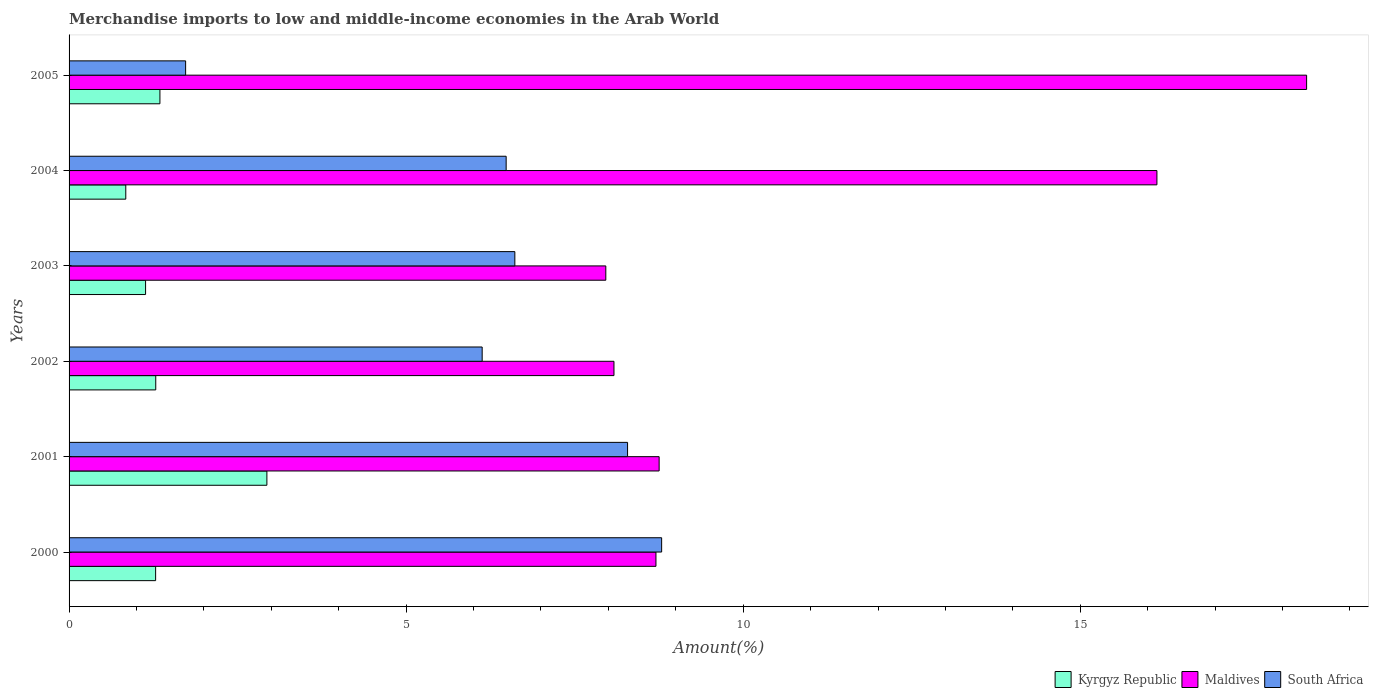Are the number of bars on each tick of the Y-axis equal?
Your answer should be very brief. Yes. How many bars are there on the 1st tick from the top?
Keep it short and to the point. 3. How many bars are there on the 4th tick from the bottom?
Make the answer very short. 3. In how many cases, is the number of bars for a given year not equal to the number of legend labels?
Your response must be concise. 0. What is the percentage of amount earned from merchandise imports in South Africa in 2005?
Keep it short and to the point. 1.73. Across all years, what is the maximum percentage of amount earned from merchandise imports in Kyrgyz Republic?
Offer a very short reply. 2.93. Across all years, what is the minimum percentage of amount earned from merchandise imports in Kyrgyz Republic?
Offer a terse response. 0.84. In which year was the percentage of amount earned from merchandise imports in Maldives minimum?
Provide a succinct answer. 2003. What is the total percentage of amount earned from merchandise imports in Maldives in the graph?
Your answer should be very brief. 68. What is the difference between the percentage of amount earned from merchandise imports in Kyrgyz Republic in 2000 and that in 2001?
Keep it short and to the point. -1.65. What is the difference between the percentage of amount earned from merchandise imports in South Africa in 2004 and the percentage of amount earned from merchandise imports in Kyrgyz Republic in 2002?
Provide a short and direct response. 5.2. What is the average percentage of amount earned from merchandise imports in South Africa per year?
Give a very brief answer. 6.34. In the year 2004, what is the difference between the percentage of amount earned from merchandise imports in Maldives and percentage of amount earned from merchandise imports in Kyrgyz Republic?
Your response must be concise. 15.3. What is the ratio of the percentage of amount earned from merchandise imports in Maldives in 2003 to that in 2005?
Offer a very short reply. 0.43. Is the difference between the percentage of amount earned from merchandise imports in Maldives in 2000 and 2001 greater than the difference between the percentage of amount earned from merchandise imports in Kyrgyz Republic in 2000 and 2001?
Give a very brief answer. Yes. What is the difference between the highest and the second highest percentage of amount earned from merchandise imports in South Africa?
Offer a terse response. 0.51. What is the difference between the highest and the lowest percentage of amount earned from merchandise imports in Maldives?
Provide a short and direct response. 10.4. In how many years, is the percentage of amount earned from merchandise imports in Kyrgyz Republic greater than the average percentage of amount earned from merchandise imports in Kyrgyz Republic taken over all years?
Provide a short and direct response. 1. Is the sum of the percentage of amount earned from merchandise imports in South Africa in 2000 and 2002 greater than the maximum percentage of amount earned from merchandise imports in Kyrgyz Republic across all years?
Your answer should be compact. Yes. What does the 1st bar from the top in 2005 represents?
Provide a succinct answer. South Africa. What does the 2nd bar from the bottom in 2001 represents?
Offer a terse response. Maldives. Are all the bars in the graph horizontal?
Keep it short and to the point. Yes. Does the graph contain any zero values?
Your response must be concise. No. Where does the legend appear in the graph?
Offer a very short reply. Bottom right. How are the legend labels stacked?
Provide a short and direct response. Horizontal. What is the title of the graph?
Give a very brief answer. Merchandise imports to low and middle-income economies in the Arab World. Does "Peru" appear as one of the legend labels in the graph?
Your answer should be very brief. No. What is the label or title of the X-axis?
Offer a terse response. Amount(%). What is the label or title of the Y-axis?
Provide a succinct answer. Years. What is the Amount(%) of Kyrgyz Republic in 2000?
Provide a succinct answer. 1.28. What is the Amount(%) of Maldives in 2000?
Your answer should be very brief. 8.71. What is the Amount(%) in South Africa in 2000?
Your response must be concise. 8.79. What is the Amount(%) in Kyrgyz Republic in 2001?
Give a very brief answer. 2.93. What is the Amount(%) of Maldives in 2001?
Provide a succinct answer. 8.75. What is the Amount(%) in South Africa in 2001?
Provide a short and direct response. 8.28. What is the Amount(%) in Kyrgyz Republic in 2002?
Offer a terse response. 1.29. What is the Amount(%) of Maldives in 2002?
Keep it short and to the point. 8.08. What is the Amount(%) of South Africa in 2002?
Offer a terse response. 6.13. What is the Amount(%) of Kyrgyz Republic in 2003?
Your answer should be compact. 1.13. What is the Amount(%) of Maldives in 2003?
Your answer should be very brief. 7.96. What is the Amount(%) in South Africa in 2003?
Your answer should be very brief. 6.61. What is the Amount(%) in Kyrgyz Republic in 2004?
Make the answer very short. 0.84. What is the Amount(%) of Maldives in 2004?
Ensure brevity in your answer.  16.14. What is the Amount(%) in South Africa in 2004?
Ensure brevity in your answer.  6.48. What is the Amount(%) of Kyrgyz Republic in 2005?
Your answer should be compact. 1.35. What is the Amount(%) of Maldives in 2005?
Your answer should be very brief. 18.36. What is the Amount(%) of South Africa in 2005?
Provide a short and direct response. 1.73. Across all years, what is the maximum Amount(%) of Kyrgyz Republic?
Ensure brevity in your answer.  2.93. Across all years, what is the maximum Amount(%) in Maldives?
Ensure brevity in your answer.  18.36. Across all years, what is the maximum Amount(%) of South Africa?
Keep it short and to the point. 8.79. Across all years, what is the minimum Amount(%) in Kyrgyz Republic?
Make the answer very short. 0.84. Across all years, what is the minimum Amount(%) in Maldives?
Offer a very short reply. 7.96. Across all years, what is the minimum Amount(%) in South Africa?
Your response must be concise. 1.73. What is the total Amount(%) in Kyrgyz Republic in the graph?
Ensure brevity in your answer.  8.83. What is the total Amount(%) in Maldives in the graph?
Give a very brief answer. 68. What is the total Amount(%) of South Africa in the graph?
Your answer should be very brief. 38.03. What is the difference between the Amount(%) of Kyrgyz Republic in 2000 and that in 2001?
Your answer should be very brief. -1.65. What is the difference between the Amount(%) of Maldives in 2000 and that in 2001?
Your response must be concise. -0.05. What is the difference between the Amount(%) of South Africa in 2000 and that in 2001?
Make the answer very short. 0.51. What is the difference between the Amount(%) in Kyrgyz Republic in 2000 and that in 2002?
Keep it short and to the point. -0. What is the difference between the Amount(%) in Maldives in 2000 and that in 2002?
Make the answer very short. 0.62. What is the difference between the Amount(%) of South Africa in 2000 and that in 2002?
Ensure brevity in your answer.  2.66. What is the difference between the Amount(%) of Kyrgyz Republic in 2000 and that in 2003?
Give a very brief answer. 0.15. What is the difference between the Amount(%) of Maldives in 2000 and that in 2003?
Your answer should be very brief. 0.74. What is the difference between the Amount(%) of South Africa in 2000 and that in 2003?
Make the answer very short. 2.18. What is the difference between the Amount(%) in Kyrgyz Republic in 2000 and that in 2004?
Provide a short and direct response. 0.44. What is the difference between the Amount(%) of Maldives in 2000 and that in 2004?
Offer a terse response. -7.43. What is the difference between the Amount(%) in South Africa in 2000 and that in 2004?
Provide a short and direct response. 2.31. What is the difference between the Amount(%) of Kyrgyz Republic in 2000 and that in 2005?
Provide a short and direct response. -0.06. What is the difference between the Amount(%) in Maldives in 2000 and that in 2005?
Your answer should be very brief. -9.65. What is the difference between the Amount(%) of South Africa in 2000 and that in 2005?
Ensure brevity in your answer.  7.06. What is the difference between the Amount(%) in Kyrgyz Republic in 2001 and that in 2002?
Your response must be concise. 1.65. What is the difference between the Amount(%) in Maldives in 2001 and that in 2002?
Your answer should be compact. 0.67. What is the difference between the Amount(%) of South Africa in 2001 and that in 2002?
Provide a succinct answer. 2.16. What is the difference between the Amount(%) in Kyrgyz Republic in 2001 and that in 2003?
Your answer should be compact. 1.8. What is the difference between the Amount(%) in Maldives in 2001 and that in 2003?
Keep it short and to the point. 0.79. What is the difference between the Amount(%) in South Africa in 2001 and that in 2003?
Your answer should be very brief. 1.67. What is the difference between the Amount(%) of Kyrgyz Republic in 2001 and that in 2004?
Keep it short and to the point. 2.09. What is the difference between the Amount(%) in Maldives in 2001 and that in 2004?
Ensure brevity in your answer.  -7.38. What is the difference between the Amount(%) in South Africa in 2001 and that in 2004?
Ensure brevity in your answer.  1.8. What is the difference between the Amount(%) in Kyrgyz Republic in 2001 and that in 2005?
Your answer should be compact. 1.59. What is the difference between the Amount(%) of Maldives in 2001 and that in 2005?
Keep it short and to the point. -9.6. What is the difference between the Amount(%) in South Africa in 2001 and that in 2005?
Ensure brevity in your answer.  6.56. What is the difference between the Amount(%) of Kyrgyz Republic in 2002 and that in 2003?
Offer a terse response. 0.15. What is the difference between the Amount(%) of Maldives in 2002 and that in 2003?
Provide a short and direct response. 0.12. What is the difference between the Amount(%) in South Africa in 2002 and that in 2003?
Keep it short and to the point. -0.48. What is the difference between the Amount(%) of Kyrgyz Republic in 2002 and that in 2004?
Your answer should be compact. 0.44. What is the difference between the Amount(%) of Maldives in 2002 and that in 2004?
Keep it short and to the point. -8.05. What is the difference between the Amount(%) of South Africa in 2002 and that in 2004?
Your response must be concise. -0.36. What is the difference between the Amount(%) in Kyrgyz Republic in 2002 and that in 2005?
Offer a terse response. -0.06. What is the difference between the Amount(%) of Maldives in 2002 and that in 2005?
Offer a very short reply. -10.27. What is the difference between the Amount(%) in South Africa in 2002 and that in 2005?
Keep it short and to the point. 4.4. What is the difference between the Amount(%) in Kyrgyz Republic in 2003 and that in 2004?
Provide a succinct answer. 0.29. What is the difference between the Amount(%) in Maldives in 2003 and that in 2004?
Provide a succinct answer. -8.18. What is the difference between the Amount(%) of South Africa in 2003 and that in 2004?
Your answer should be compact. 0.13. What is the difference between the Amount(%) in Kyrgyz Republic in 2003 and that in 2005?
Offer a terse response. -0.21. What is the difference between the Amount(%) in Maldives in 2003 and that in 2005?
Offer a very short reply. -10.4. What is the difference between the Amount(%) in South Africa in 2003 and that in 2005?
Keep it short and to the point. 4.88. What is the difference between the Amount(%) in Kyrgyz Republic in 2004 and that in 2005?
Your answer should be compact. -0.51. What is the difference between the Amount(%) of Maldives in 2004 and that in 2005?
Make the answer very short. -2.22. What is the difference between the Amount(%) in South Africa in 2004 and that in 2005?
Your answer should be compact. 4.75. What is the difference between the Amount(%) of Kyrgyz Republic in 2000 and the Amount(%) of Maldives in 2001?
Ensure brevity in your answer.  -7.47. What is the difference between the Amount(%) in Kyrgyz Republic in 2000 and the Amount(%) in South Africa in 2001?
Keep it short and to the point. -7. What is the difference between the Amount(%) of Maldives in 2000 and the Amount(%) of South Africa in 2001?
Your answer should be compact. 0.42. What is the difference between the Amount(%) of Kyrgyz Republic in 2000 and the Amount(%) of Maldives in 2002?
Offer a terse response. -6.8. What is the difference between the Amount(%) in Kyrgyz Republic in 2000 and the Amount(%) in South Africa in 2002?
Offer a terse response. -4.84. What is the difference between the Amount(%) in Maldives in 2000 and the Amount(%) in South Africa in 2002?
Keep it short and to the point. 2.58. What is the difference between the Amount(%) in Kyrgyz Republic in 2000 and the Amount(%) in Maldives in 2003?
Provide a short and direct response. -6.68. What is the difference between the Amount(%) of Kyrgyz Republic in 2000 and the Amount(%) of South Africa in 2003?
Keep it short and to the point. -5.33. What is the difference between the Amount(%) of Maldives in 2000 and the Amount(%) of South Africa in 2003?
Your answer should be compact. 2.09. What is the difference between the Amount(%) in Kyrgyz Republic in 2000 and the Amount(%) in Maldives in 2004?
Make the answer very short. -14.85. What is the difference between the Amount(%) in Kyrgyz Republic in 2000 and the Amount(%) in South Africa in 2004?
Provide a short and direct response. -5.2. What is the difference between the Amount(%) of Maldives in 2000 and the Amount(%) of South Africa in 2004?
Provide a succinct answer. 2.22. What is the difference between the Amount(%) in Kyrgyz Republic in 2000 and the Amount(%) in Maldives in 2005?
Provide a short and direct response. -17.07. What is the difference between the Amount(%) in Kyrgyz Republic in 2000 and the Amount(%) in South Africa in 2005?
Keep it short and to the point. -0.45. What is the difference between the Amount(%) of Maldives in 2000 and the Amount(%) of South Africa in 2005?
Your response must be concise. 6.98. What is the difference between the Amount(%) of Kyrgyz Republic in 2001 and the Amount(%) of Maldives in 2002?
Keep it short and to the point. -5.15. What is the difference between the Amount(%) in Kyrgyz Republic in 2001 and the Amount(%) in South Africa in 2002?
Give a very brief answer. -3.19. What is the difference between the Amount(%) in Maldives in 2001 and the Amount(%) in South Africa in 2002?
Provide a short and direct response. 2.63. What is the difference between the Amount(%) of Kyrgyz Republic in 2001 and the Amount(%) of Maldives in 2003?
Give a very brief answer. -5.03. What is the difference between the Amount(%) of Kyrgyz Republic in 2001 and the Amount(%) of South Africa in 2003?
Provide a short and direct response. -3.68. What is the difference between the Amount(%) of Maldives in 2001 and the Amount(%) of South Africa in 2003?
Your response must be concise. 2.14. What is the difference between the Amount(%) of Kyrgyz Republic in 2001 and the Amount(%) of Maldives in 2004?
Offer a very short reply. -13.2. What is the difference between the Amount(%) in Kyrgyz Republic in 2001 and the Amount(%) in South Africa in 2004?
Offer a very short reply. -3.55. What is the difference between the Amount(%) in Maldives in 2001 and the Amount(%) in South Africa in 2004?
Offer a very short reply. 2.27. What is the difference between the Amount(%) in Kyrgyz Republic in 2001 and the Amount(%) in Maldives in 2005?
Keep it short and to the point. -15.42. What is the difference between the Amount(%) of Kyrgyz Republic in 2001 and the Amount(%) of South Africa in 2005?
Provide a short and direct response. 1.21. What is the difference between the Amount(%) in Maldives in 2001 and the Amount(%) in South Africa in 2005?
Offer a terse response. 7.02. What is the difference between the Amount(%) in Kyrgyz Republic in 2002 and the Amount(%) in Maldives in 2003?
Make the answer very short. -6.68. What is the difference between the Amount(%) of Kyrgyz Republic in 2002 and the Amount(%) of South Africa in 2003?
Provide a succinct answer. -5.33. What is the difference between the Amount(%) in Maldives in 2002 and the Amount(%) in South Africa in 2003?
Offer a very short reply. 1.47. What is the difference between the Amount(%) in Kyrgyz Republic in 2002 and the Amount(%) in Maldives in 2004?
Your answer should be compact. -14.85. What is the difference between the Amount(%) in Kyrgyz Republic in 2002 and the Amount(%) in South Africa in 2004?
Give a very brief answer. -5.2. What is the difference between the Amount(%) of Maldives in 2002 and the Amount(%) of South Africa in 2004?
Your answer should be compact. 1.6. What is the difference between the Amount(%) in Kyrgyz Republic in 2002 and the Amount(%) in Maldives in 2005?
Provide a succinct answer. -17.07. What is the difference between the Amount(%) of Kyrgyz Republic in 2002 and the Amount(%) of South Africa in 2005?
Offer a terse response. -0.44. What is the difference between the Amount(%) in Maldives in 2002 and the Amount(%) in South Africa in 2005?
Your answer should be compact. 6.35. What is the difference between the Amount(%) in Kyrgyz Republic in 2003 and the Amount(%) in Maldives in 2004?
Provide a succinct answer. -15. What is the difference between the Amount(%) of Kyrgyz Republic in 2003 and the Amount(%) of South Africa in 2004?
Offer a terse response. -5.35. What is the difference between the Amount(%) in Maldives in 2003 and the Amount(%) in South Africa in 2004?
Offer a terse response. 1.48. What is the difference between the Amount(%) of Kyrgyz Republic in 2003 and the Amount(%) of Maldives in 2005?
Offer a very short reply. -17.22. What is the difference between the Amount(%) of Kyrgyz Republic in 2003 and the Amount(%) of South Africa in 2005?
Provide a short and direct response. -0.59. What is the difference between the Amount(%) of Maldives in 2003 and the Amount(%) of South Africa in 2005?
Keep it short and to the point. 6.23. What is the difference between the Amount(%) of Kyrgyz Republic in 2004 and the Amount(%) of Maldives in 2005?
Ensure brevity in your answer.  -17.52. What is the difference between the Amount(%) of Kyrgyz Republic in 2004 and the Amount(%) of South Africa in 2005?
Offer a very short reply. -0.89. What is the difference between the Amount(%) of Maldives in 2004 and the Amount(%) of South Africa in 2005?
Provide a short and direct response. 14.41. What is the average Amount(%) in Kyrgyz Republic per year?
Ensure brevity in your answer.  1.47. What is the average Amount(%) in Maldives per year?
Keep it short and to the point. 11.33. What is the average Amount(%) in South Africa per year?
Provide a succinct answer. 6.34. In the year 2000, what is the difference between the Amount(%) in Kyrgyz Republic and Amount(%) in Maldives?
Your answer should be very brief. -7.42. In the year 2000, what is the difference between the Amount(%) of Kyrgyz Republic and Amount(%) of South Africa?
Your answer should be very brief. -7.51. In the year 2000, what is the difference between the Amount(%) of Maldives and Amount(%) of South Africa?
Your answer should be very brief. -0.08. In the year 2001, what is the difference between the Amount(%) of Kyrgyz Republic and Amount(%) of Maldives?
Keep it short and to the point. -5.82. In the year 2001, what is the difference between the Amount(%) of Kyrgyz Republic and Amount(%) of South Africa?
Offer a very short reply. -5.35. In the year 2001, what is the difference between the Amount(%) in Maldives and Amount(%) in South Africa?
Offer a terse response. 0.47. In the year 2002, what is the difference between the Amount(%) in Kyrgyz Republic and Amount(%) in Maldives?
Make the answer very short. -6.8. In the year 2002, what is the difference between the Amount(%) of Kyrgyz Republic and Amount(%) of South Africa?
Offer a terse response. -4.84. In the year 2002, what is the difference between the Amount(%) in Maldives and Amount(%) in South Africa?
Make the answer very short. 1.96. In the year 2003, what is the difference between the Amount(%) of Kyrgyz Republic and Amount(%) of Maldives?
Offer a terse response. -6.83. In the year 2003, what is the difference between the Amount(%) in Kyrgyz Republic and Amount(%) in South Africa?
Provide a succinct answer. -5.48. In the year 2003, what is the difference between the Amount(%) in Maldives and Amount(%) in South Africa?
Provide a short and direct response. 1.35. In the year 2004, what is the difference between the Amount(%) of Kyrgyz Republic and Amount(%) of Maldives?
Keep it short and to the point. -15.3. In the year 2004, what is the difference between the Amount(%) in Kyrgyz Republic and Amount(%) in South Africa?
Give a very brief answer. -5.64. In the year 2004, what is the difference between the Amount(%) of Maldives and Amount(%) of South Africa?
Provide a short and direct response. 9.65. In the year 2005, what is the difference between the Amount(%) of Kyrgyz Republic and Amount(%) of Maldives?
Give a very brief answer. -17.01. In the year 2005, what is the difference between the Amount(%) in Kyrgyz Republic and Amount(%) in South Africa?
Your answer should be very brief. -0.38. In the year 2005, what is the difference between the Amount(%) of Maldives and Amount(%) of South Africa?
Give a very brief answer. 16.63. What is the ratio of the Amount(%) in Kyrgyz Republic in 2000 to that in 2001?
Make the answer very short. 0.44. What is the ratio of the Amount(%) in Maldives in 2000 to that in 2001?
Ensure brevity in your answer.  0.99. What is the ratio of the Amount(%) of South Africa in 2000 to that in 2001?
Offer a terse response. 1.06. What is the ratio of the Amount(%) of Kyrgyz Republic in 2000 to that in 2002?
Your response must be concise. 1. What is the ratio of the Amount(%) of Maldives in 2000 to that in 2002?
Offer a very short reply. 1.08. What is the ratio of the Amount(%) in South Africa in 2000 to that in 2002?
Your answer should be compact. 1.43. What is the ratio of the Amount(%) of Kyrgyz Republic in 2000 to that in 2003?
Keep it short and to the point. 1.13. What is the ratio of the Amount(%) of Maldives in 2000 to that in 2003?
Provide a succinct answer. 1.09. What is the ratio of the Amount(%) of South Africa in 2000 to that in 2003?
Offer a very short reply. 1.33. What is the ratio of the Amount(%) in Kyrgyz Republic in 2000 to that in 2004?
Keep it short and to the point. 1.53. What is the ratio of the Amount(%) of Maldives in 2000 to that in 2004?
Your response must be concise. 0.54. What is the ratio of the Amount(%) in South Africa in 2000 to that in 2004?
Provide a short and direct response. 1.36. What is the ratio of the Amount(%) in Kyrgyz Republic in 2000 to that in 2005?
Provide a short and direct response. 0.95. What is the ratio of the Amount(%) in Maldives in 2000 to that in 2005?
Keep it short and to the point. 0.47. What is the ratio of the Amount(%) of South Africa in 2000 to that in 2005?
Your answer should be very brief. 5.08. What is the ratio of the Amount(%) of Kyrgyz Republic in 2001 to that in 2002?
Your answer should be compact. 2.28. What is the ratio of the Amount(%) of Maldives in 2001 to that in 2002?
Your answer should be very brief. 1.08. What is the ratio of the Amount(%) in South Africa in 2001 to that in 2002?
Your answer should be very brief. 1.35. What is the ratio of the Amount(%) of Kyrgyz Republic in 2001 to that in 2003?
Offer a very short reply. 2.59. What is the ratio of the Amount(%) in Maldives in 2001 to that in 2003?
Offer a terse response. 1.1. What is the ratio of the Amount(%) of South Africa in 2001 to that in 2003?
Keep it short and to the point. 1.25. What is the ratio of the Amount(%) of Kyrgyz Republic in 2001 to that in 2004?
Provide a short and direct response. 3.49. What is the ratio of the Amount(%) in Maldives in 2001 to that in 2004?
Make the answer very short. 0.54. What is the ratio of the Amount(%) of South Africa in 2001 to that in 2004?
Make the answer very short. 1.28. What is the ratio of the Amount(%) in Kyrgyz Republic in 2001 to that in 2005?
Keep it short and to the point. 2.18. What is the ratio of the Amount(%) in Maldives in 2001 to that in 2005?
Ensure brevity in your answer.  0.48. What is the ratio of the Amount(%) in South Africa in 2001 to that in 2005?
Your answer should be very brief. 4.79. What is the ratio of the Amount(%) of Kyrgyz Republic in 2002 to that in 2003?
Your response must be concise. 1.13. What is the ratio of the Amount(%) in Maldives in 2002 to that in 2003?
Make the answer very short. 1.02. What is the ratio of the Amount(%) of South Africa in 2002 to that in 2003?
Your response must be concise. 0.93. What is the ratio of the Amount(%) in Kyrgyz Republic in 2002 to that in 2004?
Offer a very short reply. 1.53. What is the ratio of the Amount(%) of Maldives in 2002 to that in 2004?
Your answer should be compact. 0.5. What is the ratio of the Amount(%) of South Africa in 2002 to that in 2004?
Make the answer very short. 0.95. What is the ratio of the Amount(%) in Kyrgyz Republic in 2002 to that in 2005?
Ensure brevity in your answer.  0.95. What is the ratio of the Amount(%) in Maldives in 2002 to that in 2005?
Keep it short and to the point. 0.44. What is the ratio of the Amount(%) in South Africa in 2002 to that in 2005?
Ensure brevity in your answer.  3.54. What is the ratio of the Amount(%) of Kyrgyz Republic in 2003 to that in 2004?
Offer a terse response. 1.35. What is the ratio of the Amount(%) of Maldives in 2003 to that in 2004?
Ensure brevity in your answer.  0.49. What is the ratio of the Amount(%) in South Africa in 2003 to that in 2004?
Your answer should be compact. 1.02. What is the ratio of the Amount(%) of Kyrgyz Republic in 2003 to that in 2005?
Offer a terse response. 0.84. What is the ratio of the Amount(%) in Maldives in 2003 to that in 2005?
Provide a succinct answer. 0.43. What is the ratio of the Amount(%) in South Africa in 2003 to that in 2005?
Provide a short and direct response. 3.82. What is the ratio of the Amount(%) in Kyrgyz Republic in 2004 to that in 2005?
Give a very brief answer. 0.62. What is the ratio of the Amount(%) in Maldives in 2004 to that in 2005?
Keep it short and to the point. 0.88. What is the ratio of the Amount(%) in South Africa in 2004 to that in 2005?
Provide a succinct answer. 3.75. What is the difference between the highest and the second highest Amount(%) in Kyrgyz Republic?
Your response must be concise. 1.59. What is the difference between the highest and the second highest Amount(%) in Maldives?
Your answer should be compact. 2.22. What is the difference between the highest and the second highest Amount(%) in South Africa?
Your response must be concise. 0.51. What is the difference between the highest and the lowest Amount(%) of Kyrgyz Republic?
Offer a terse response. 2.09. What is the difference between the highest and the lowest Amount(%) of Maldives?
Provide a succinct answer. 10.4. What is the difference between the highest and the lowest Amount(%) in South Africa?
Provide a succinct answer. 7.06. 